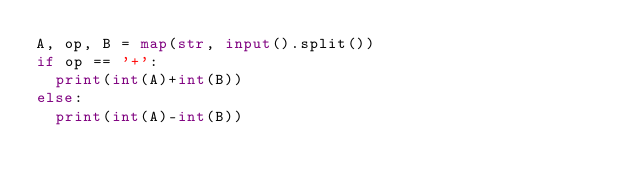Convert code to text. <code><loc_0><loc_0><loc_500><loc_500><_Python_>A, op, B = map(str, input().split())
if op == '+':
  print(int(A)+int(B))
else:
  print(int(A)-int(B))
</code> 